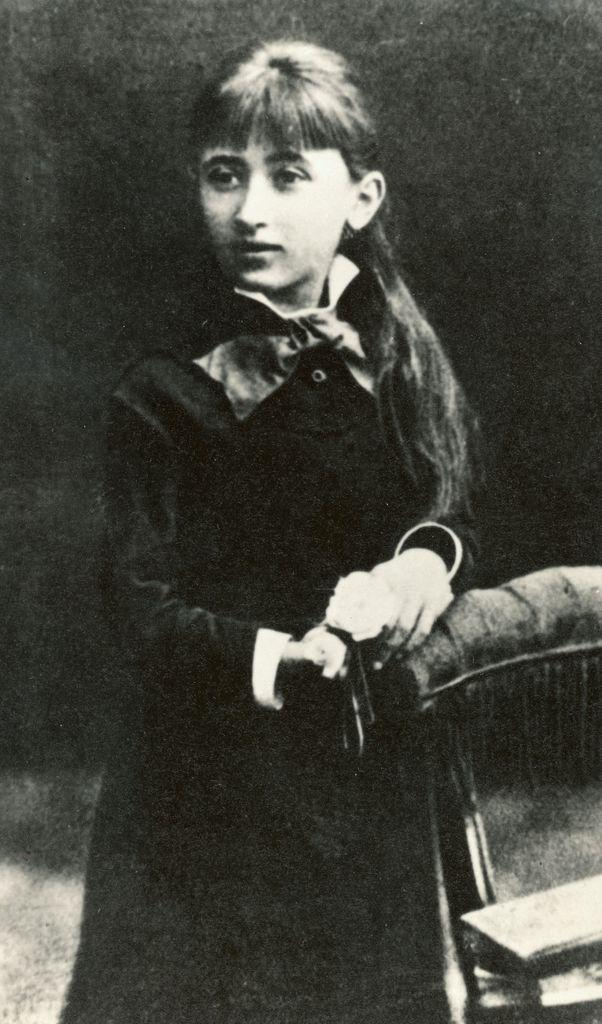What is the color scheme of the image? The image is in black and white. Who is the main subject in the image? There is a girl in the image. What is the girl holding in the image? The girl is holding a chair. Who is the girl looking at in the image? The girl is looking at someone. What type of iron is the girl using to press her clothes in the image? There is no iron present in the image; it is a girl holding a chair and looking at someone. What kind of celery is the girl eating in the image? There is no celery present in the image; it is a girl holding a chair and looking at someone. 